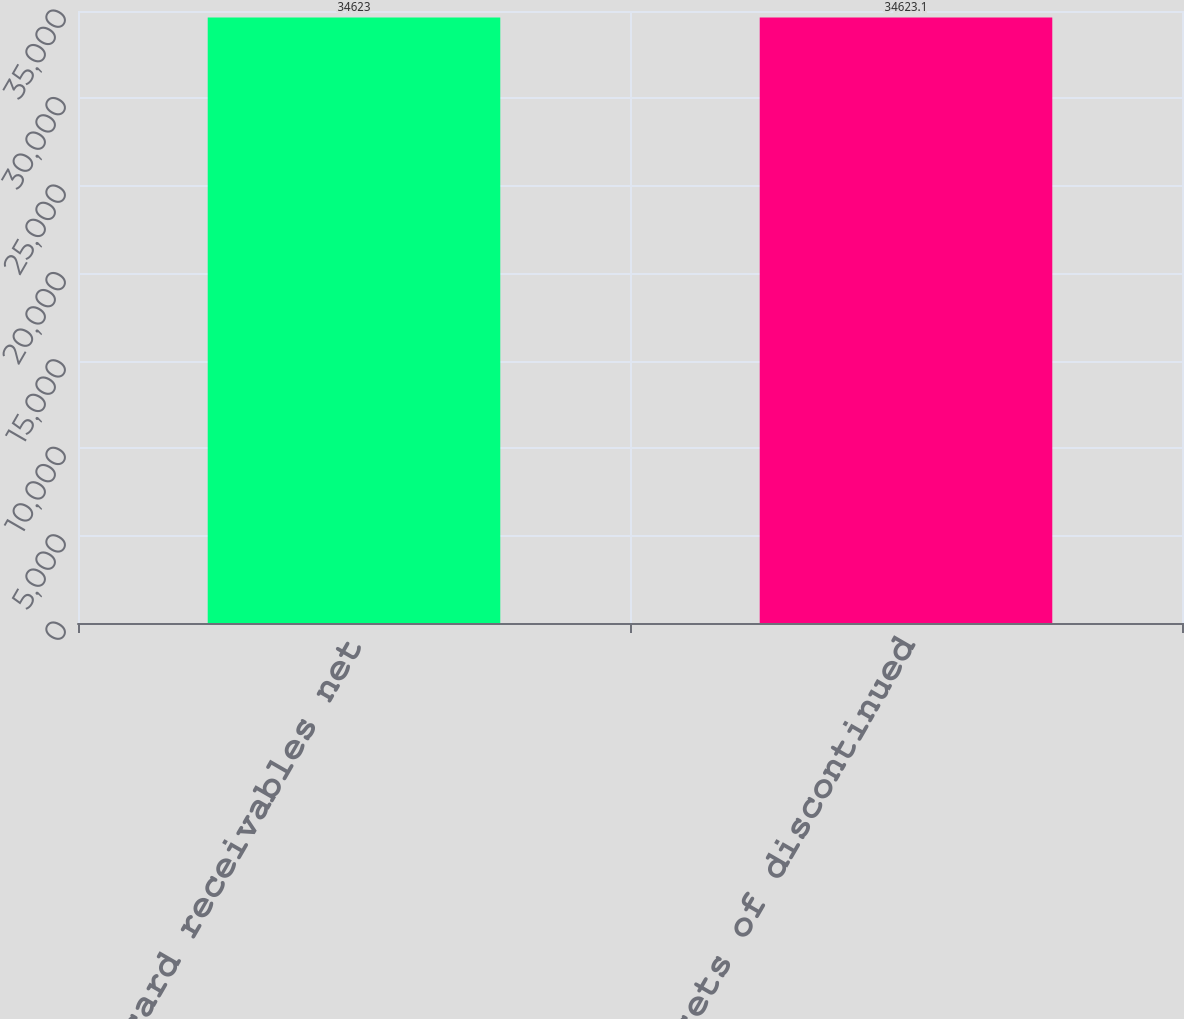Convert chart. <chart><loc_0><loc_0><loc_500><loc_500><bar_chart><fcel>Credit card receivables net<fcel>Assets of discontinued<nl><fcel>34623<fcel>34623.1<nl></chart> 